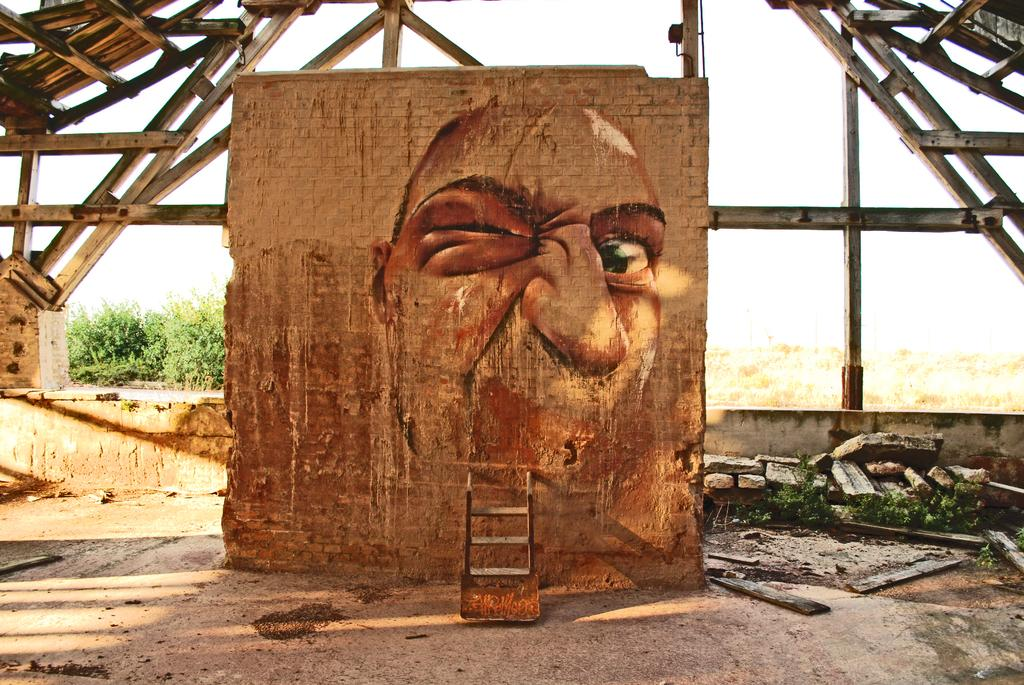What type of structure is visible in the image? There is a brick wall in the image. What is on the brick wall? There is a painting on the brick wall. What can be seen in the background of the image? There are poles visible in the background of the image. How many apples are hanging from the coach in the image? There is no coach or apples present in the image. 